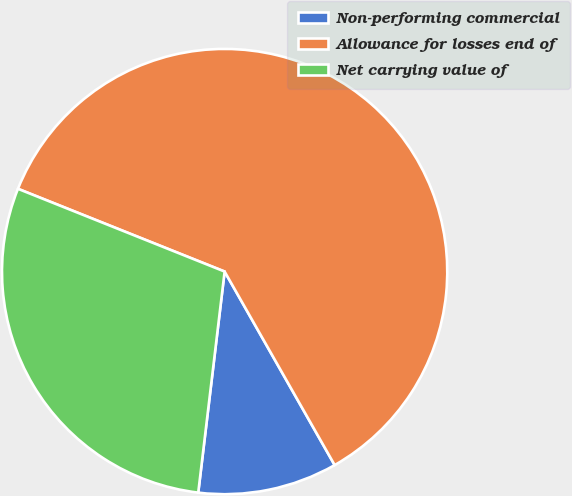<chart> <loc_0><loc_0><loc_500><loc_500><pie_chart><fcel>Non-performing commercial<fcel>Allowance for losses end of<fcel>Net carrying value of<nl><fcel>10.12%<fcel>60.71%<fcel>29.17%<nl></chart> 